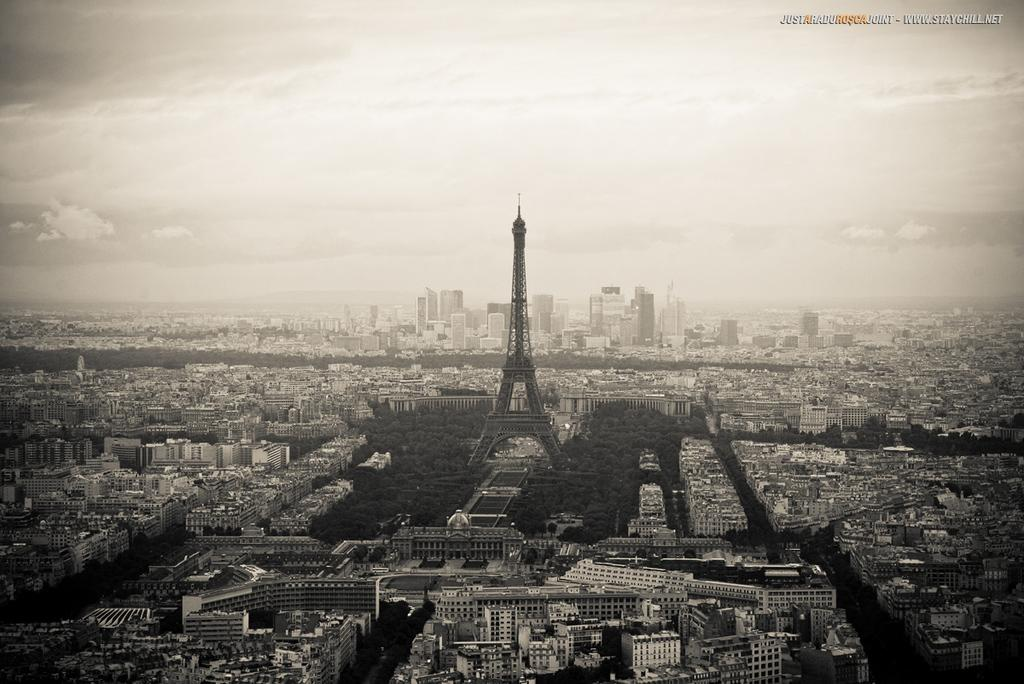What type of structures can be seen in the image? There are buildings in the image. What architectural feature is visible on the buildings? There are windows visible in the image. What type of vegetation is present in the image? There are trees in the image. What stands out as a tall structure in the image? There is a tower in the image. How is the image presented in terms of color? The image is in black and white. Where is the grandmother sitting in the yard during lunchtime in the image? There is no grandmother, yard, or lunchtime depicted in the image; it features buildings, windows, trees, a tower, and is in black and white. 